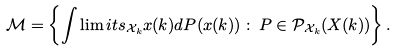<formula> <loc_0><loc_0><loc_500><loc_500>\mathcal { M } = \left \{ \int \lim i t s _ { \mathcal { X } _ { k } } x ( k ) d P ( x ( k ) ) \, \colon \, P \in \mathcal { P } _ { \mathcal { X } _ { k } } ( X ( k ) ) \right \} .</formula> 